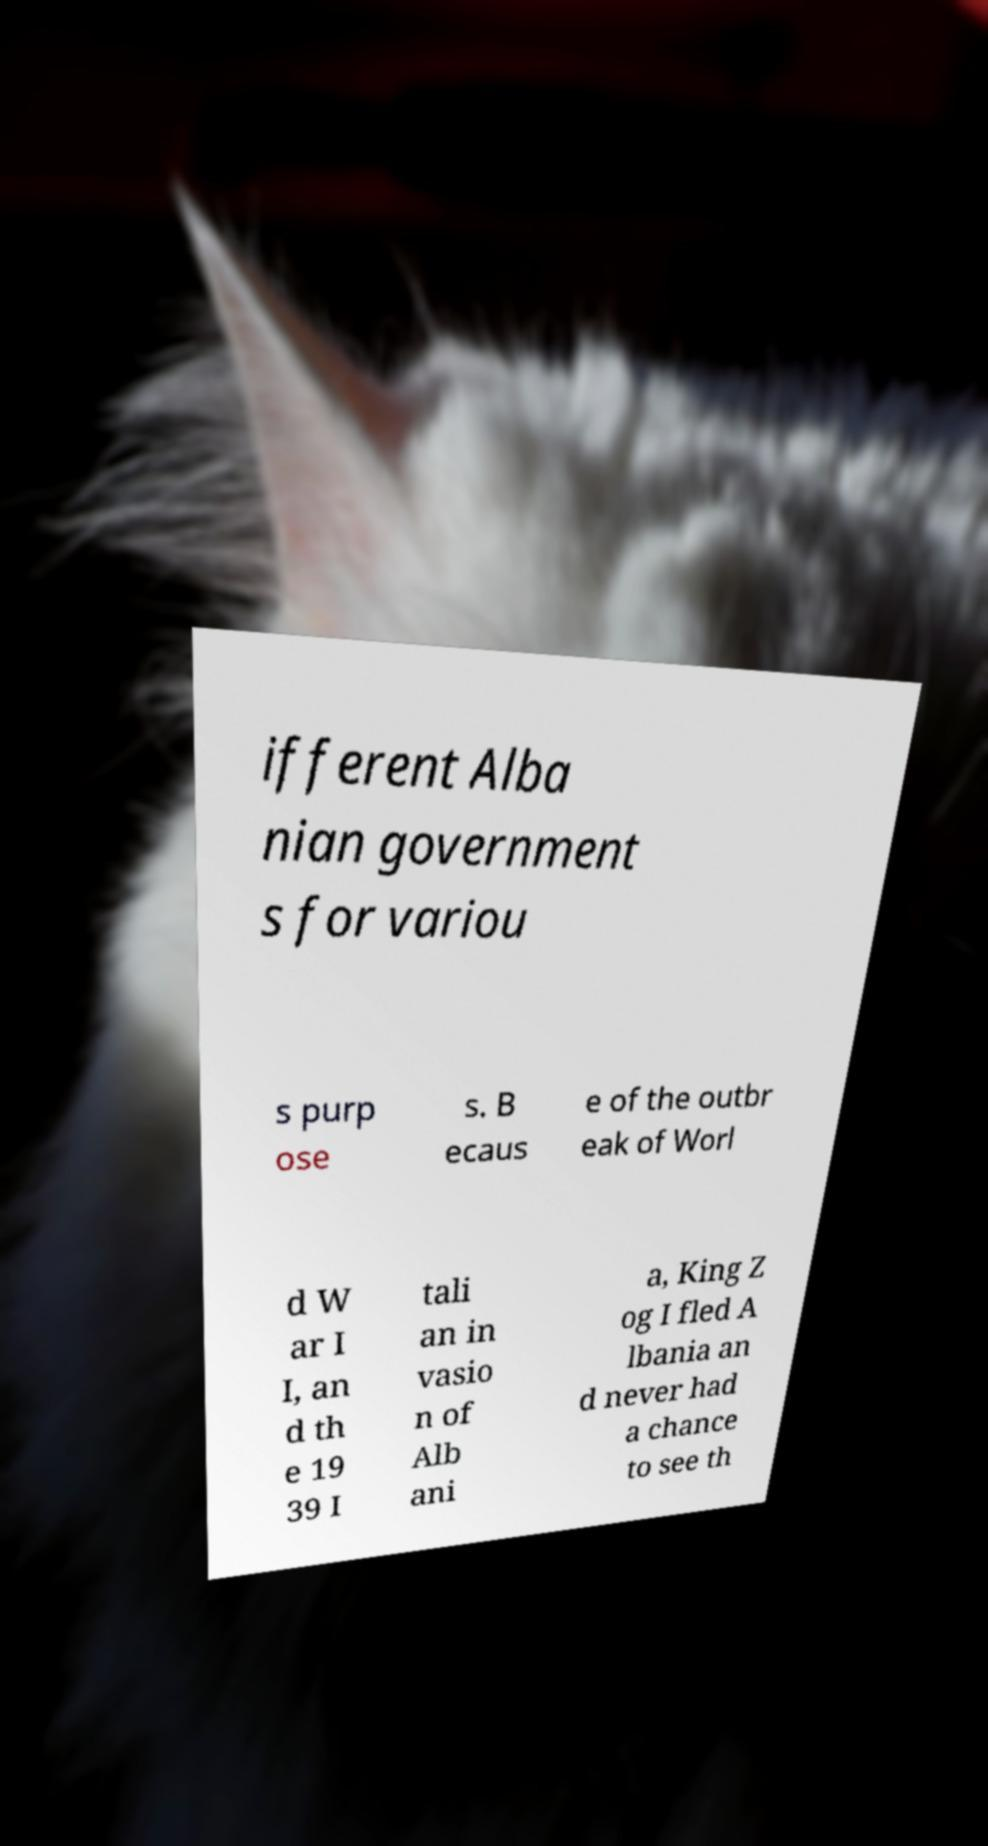Can you read and provide the text displayed in the image?This photo seems to have some interesting text. Can you extract and type it out for me? ifferent Alba nian government s for variou s purp ose s. B ecaus e of the outbr eak of Worl d W ar I I, an d th e 19 39 I tali an in vasio n of Alb ani a, King Z og I fled A lbania an d never had a chance to see th 